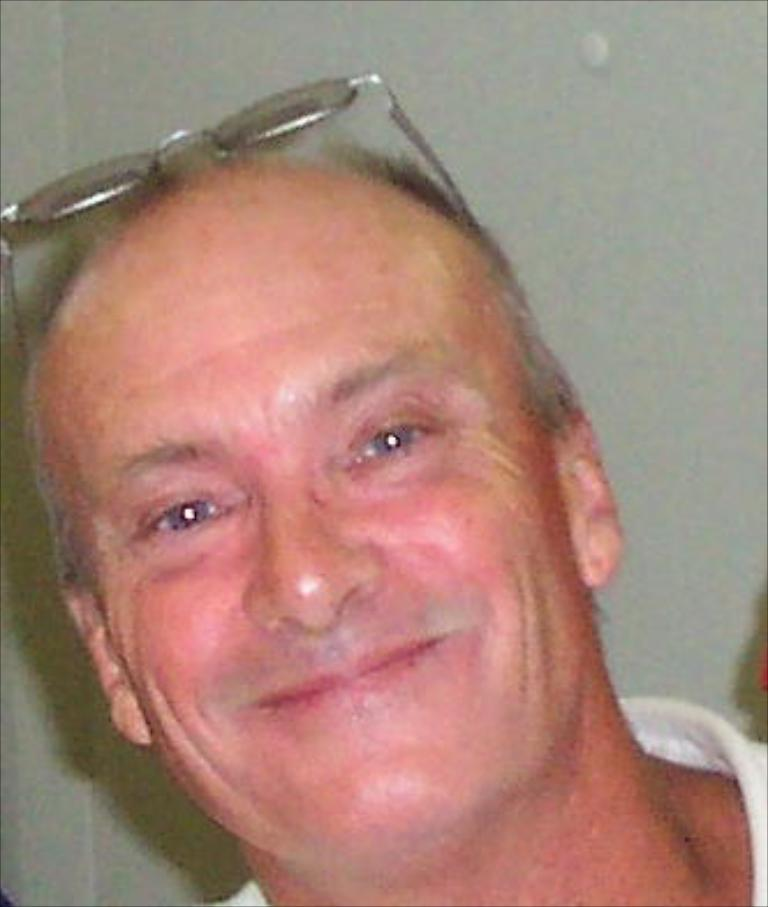Who is present in the image? There is a man in the image. What is the man doing in the image? The man is smiling in the image. What can be seen on the man's head? The man has spectacles on his head. What is the color of the background in the image? The background of the image is white in color. Can you see the ocean in the background of the image? No, there is no ocean visible in the image; the background is white in color. 